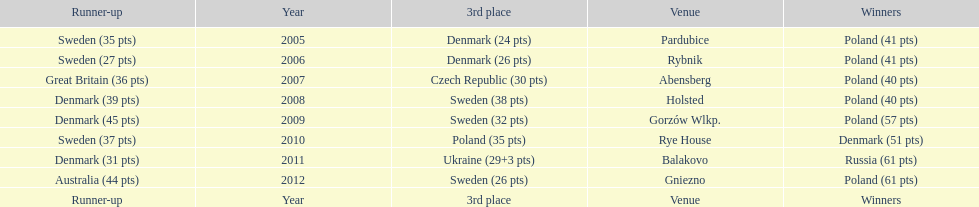What was the last year 3rd place finished with less than 25 points? 2005. 